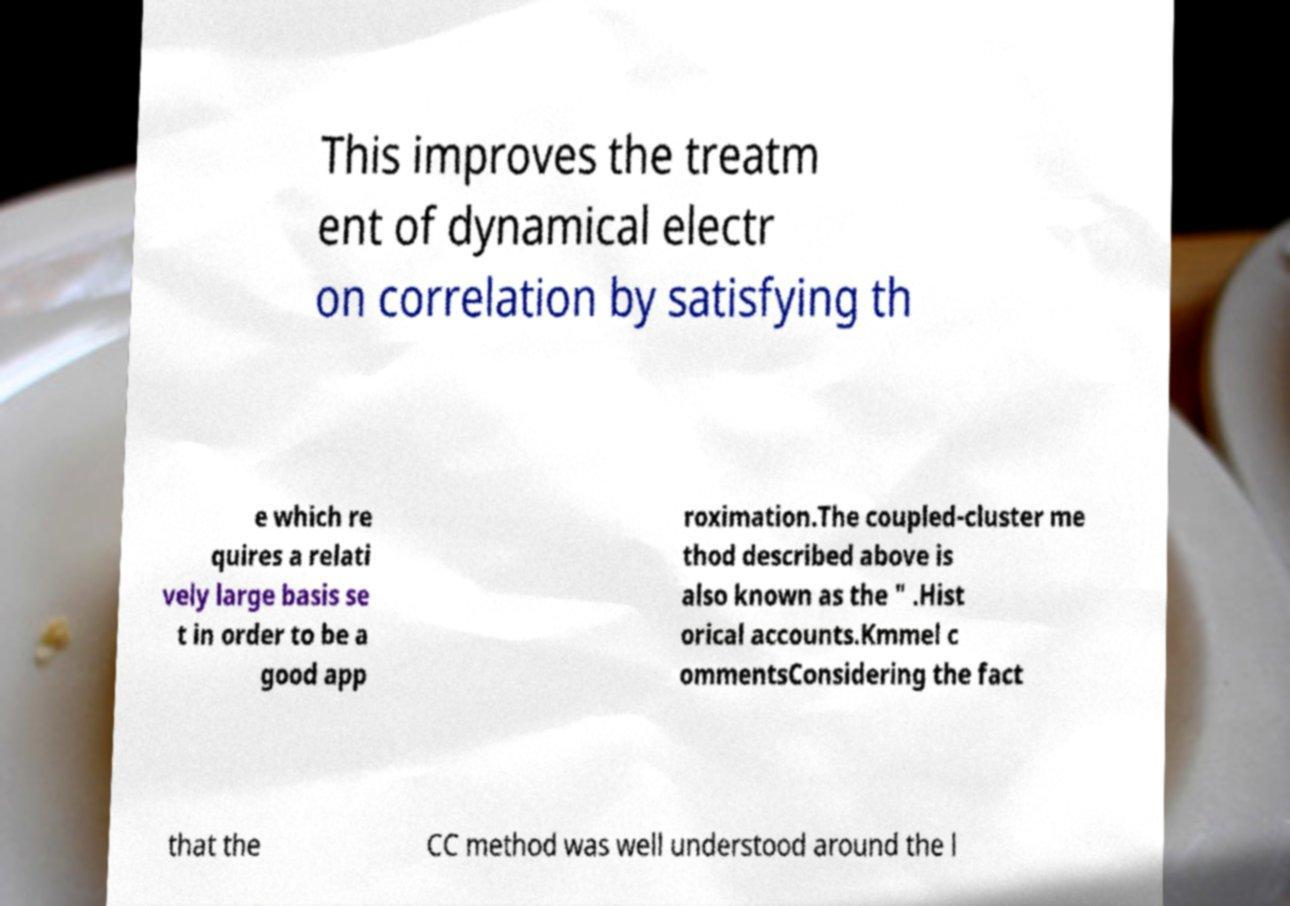Could you extract and type out the text from this image? This improves the treatm ent of dynamical electr on correlation by satisfying th e which re quires a relati vely large basis se t in order to be a good app roximation.The coupled-cluster me thod described above is also known as the " .Hist orical accounts.Kmmel c ommentsConsidering the fact that the CC method was well understood around the l 